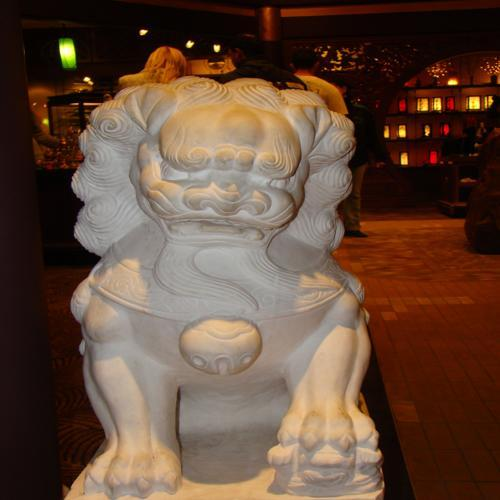Can you tell me more about what this statue represents? The statue in the image is representative of a 'guardian lion,' commonly found in Chinese culture. These statues are often placed at the entrance of buildings and serve as protectors or symbols of power and prestige. They are deeply rooted in Chinese mythology and are believed to hold mystical protective powers. 